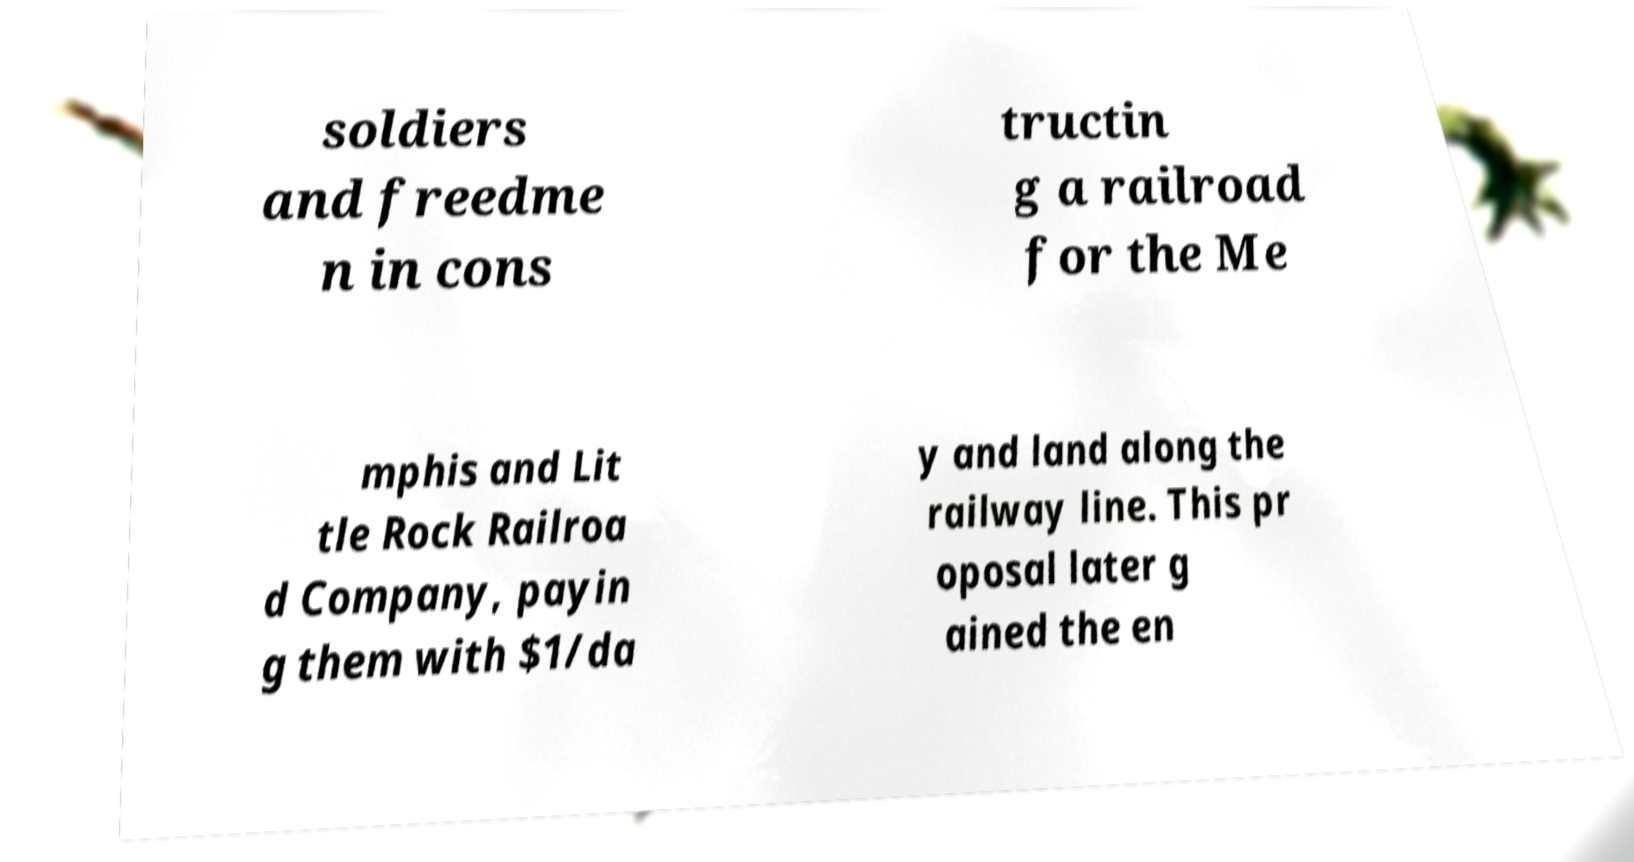Could you extract and type out the text from this image? soldiers and freedme n in cons tructin g a railroad for the Me mphis and Lit tle Rock Railroa d Company, payin g them with $1/da y and land along the railway line. This pr oposal later g ained the en 